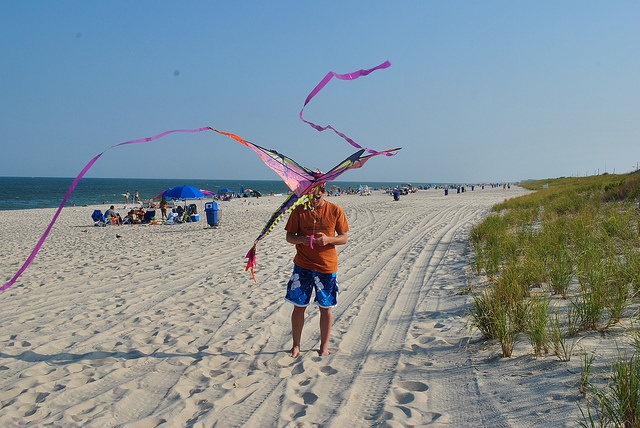Describe the objects in this image and their specific colors. I can see people in gray, maroon, black, navy, and brown tones, kite in gray, darkgray, and purple tones, umbrella in gray, blue, navy, and darkblue tones, people in gray, black, navy, and brown tones, and chair in gray, navy, black, and darkblue tones in this image. 